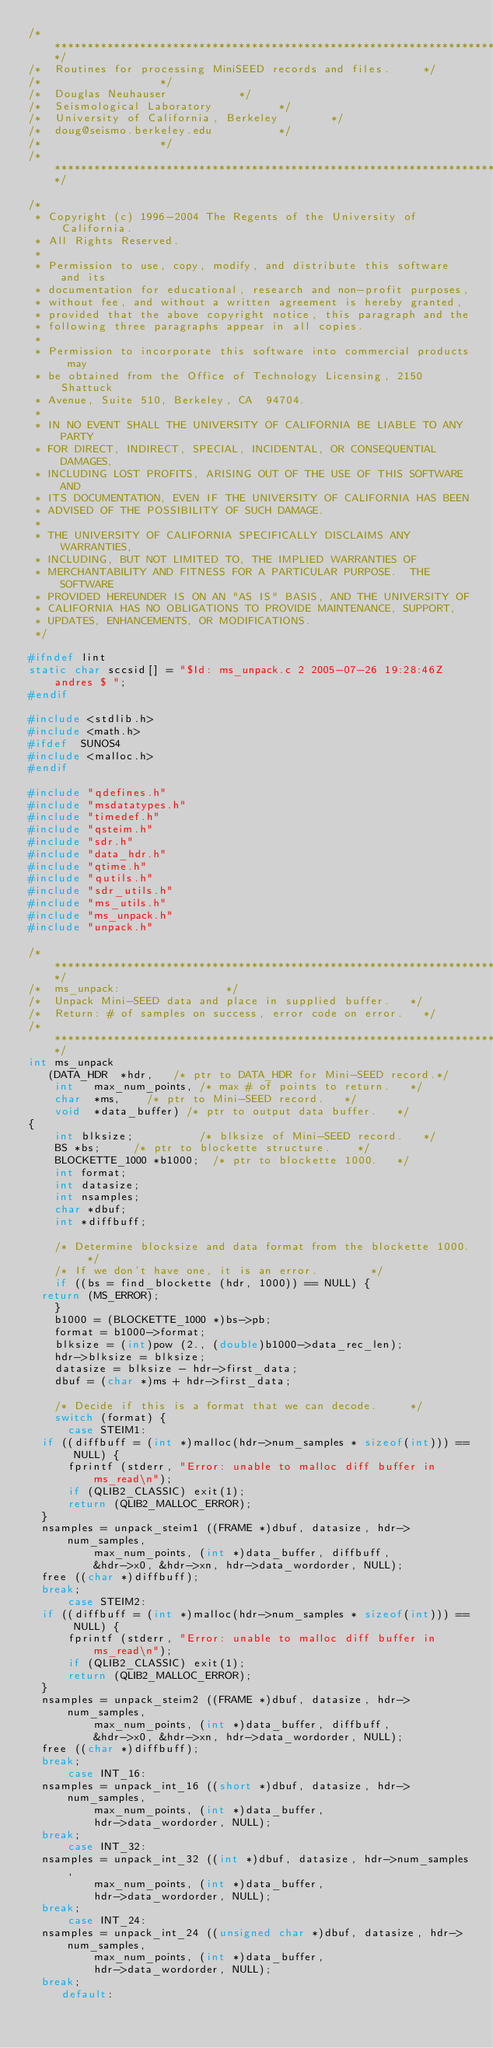Convert code to text. <code><loc_0><loc_0><loc_500><loc_500><_C_>/************************************************************************/
/*  Routines for processing MiniSEED records and files.			*/
/*									*/
/*	Douglas Neuhauser						*/
/*	Seismological Laboratory					*/
/*	University of California, Berkeley				*/
/*	doug@seismo.berkeley.edu					*/
/*									*/
/************************************************************************/

/*
 * Copyright (c) 1996-2004 The Regents of the University of California.
 * All Rights Reserved.
 * 
 * Permission to use, copy, modify, and distribute this software and its
 * documentation for educational, research and non-profit purposes,
 * without fee, and without a written agreement is hereby granted,
 * provided that the above copyright notice, this paragraph and the
 * following three paragraphs appear in all copies.
 * 
 * Permission to incorporate this software into commercial products may
 * be obtained from the Office of Technology Licensing, 2150 Shattuck
 * Avenue, Suite 510, Berkeley, CA  94704.
 * 
 * IN NO EVENT SHALL THE UNIVERSITY OF CALIFORNIA BE LIABLE TO ANY PARTY
 * FOR DIRECT, INDIRECT, SPECIAL, INCIDENTAL, OR CONSEQUENTIAL DAMAGES,
 * INCLUDING LOST PROFITS, ARISING OUT OF THE USE OF THIS SOFTWARE AND
 * ITS DOCUMENTATION, EVEN IF THE UNIVERSITY OF CALIFORNIA HAS BEEN
 * ADVISED OF THE POSSIBILITY OF SUCH DAMAGE.
 * 
 * THE UNIVERSITY OF CALIFORNIA SPECIFICALLY DISCLAIMS ANY WARRANTIES,
 * INCLUDING, BUT NOT LIMITED TO, THE IMPLIED WARRANTIES OF
 * MERCHANTABILITY AND FITNESS FOR A PARTICULAR PURPOSE.  THE SOFTWARE
 * PROVIDED HEREUNDER IS ON AN "AS IS" BASIS, AND THE UNIVERSITY OF
 * CALIFORNIA HAS NO OBLIGATIONS TO PROVIDE MAINTENANCE, SUPPORT,
 * UPDATES, ENHANCEMENTS, OR MODIFICATIONS.
 */

#ifndef lint
static char sccsid[] = "$Id: ms_unpack.c 2 2005-07-26 19:28:46Z andres $ ";
#endif

#include <stdlib.h>
#include <math.h>
#ifdef	SUNOS4
#include <malloc.h>
#endif

#include "qdefines.h"
#include "msdatatypes.h"
#include "timedef.h"
#include "qsteim.h"
#include "sdr.h"
#include "data_hdr.h"
#include "qtime.h"
#include "qutils.h"
#include "sdr_utils.h"
#include "ms_utils.h"
#include "ms_unpack.h"
#include "unpack.h"

/************************************************************************/
/*  ms_unpack:								*/
/*	Unpack Mini-SEED data and place in supplied buffer.		*/
/*  Return:	# of samples on success, error code on error.		*/
/************************************************************************/
int ms_unpack 
   (DATA_HDR	*hdr,		/* ptr to DATA_HDR for Mini-SEED record.*/
    int		max_num_points,	/* max # of points to return.		*/
    char	*ms,		/* ptr to Mini-SEED record.		*/
    void	*data_buffer)	/* ptr to output data buffer.		*/
{
    int blksize;	       	/* blksize of Mini-SEED record.		*/
    BS *bs;			/* ptr to blockette structure.		*/
    BLOCKETTE_1000 *b1000;	/* ptr to blockette 1000.		*/
    int format;
    int datasize;
    int nsamples;
    char *dbuf;
    int *diffbuff;

    /* Determine blocksize and data format from the blockette 1000.	*/
    /* If we don't have one, it is an error.				*/
    if ((bs = find_blockette (hdr, 1000)) == NULL) {
	return (MS_ERROR);
    }
    b1000 = (BLOCKETTE_1000 *)bs->pb;
    format = b1000->format;
    blksize = (int)pow (2., (double)b1000->data_rec_len);
    hdr->blksize = blksize;
    datasize = blksize - hdr->first_data;
    dbuf = (char *)ms + hdr->first_data;

    /* Decide if this is a format that we can decode.			*/
    switch (format) {
      case STEIM1:
	if ((diffbuff = (int *)malloc(hdr->num_samples * sizeof(int))) == NULL) {
	    fprintf (stderr, "Error: unable to malloc diff buffer in ms_read\n");
	    if (QLIB2_CLASSIC) exit(1);
	    return (QLIB2_MALLOC_ERROR);
	}
	nsamples = unpack_steim1 ((FRAME *)dbuf, datasize, hdr->num_samples,
				  max_num_points, (int *)data_buffer, diffbuff, 
				  &hdr->x0, &hdr->xn, hdr->data_wordorder, NULL);
	free ((char *)diffbuff);
	break;
      case STEIM2:
	if ((diffbuff = (int *)malloc(hdr->num_samples * sizeof(int))) == NULL) {
	    fprintf (stderr, "Error: unable to malloc diff buffer in ms_read\n");
	    if (QLIB2_CLASSIC) exit(1);
	    return (QLIB2_MALLOC_ERROR);
	}
	nsamples = unpack_steim2 ((FRAME *)dbuf, datasize, hdr->num_samples,
				  max_num_points, (int *)data_buffer, diffbuff, 
				  &hdr->x0, &hdr->xn, hdr->data_wordorder, NULL);
	free ((char *)diffbuff);
	break;
      case INT_16:
	nsamples = unpack_int_16 ((short *)dbuf, datasize, hdr->num_samples,
				  max_num_points, (int *)data_buffer, 
				  hdr->data_wordorder, NULL);
	break;
      case INT_32:
	nsamples = unpack_int_32 ((int *)dbuf, datasize, hdr->num_samples,
				  max_num_points, (int *)data_buffer, 
				  hdr->data_wordorder, NULL);
	break;
      case INT_24:
	nsamples = unpack_int_24 ((unsigned char *)dbuf, datasize, hdr->num_samples,
				  max_num_points, (int *)data_buffer, 
				  hdr->data_wordorder, NULL);
	break;
     default:</code> 